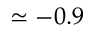<formula> <loc_0><loc_0><loc_500><loc_500>\simeq - 0 . 9</formula> 